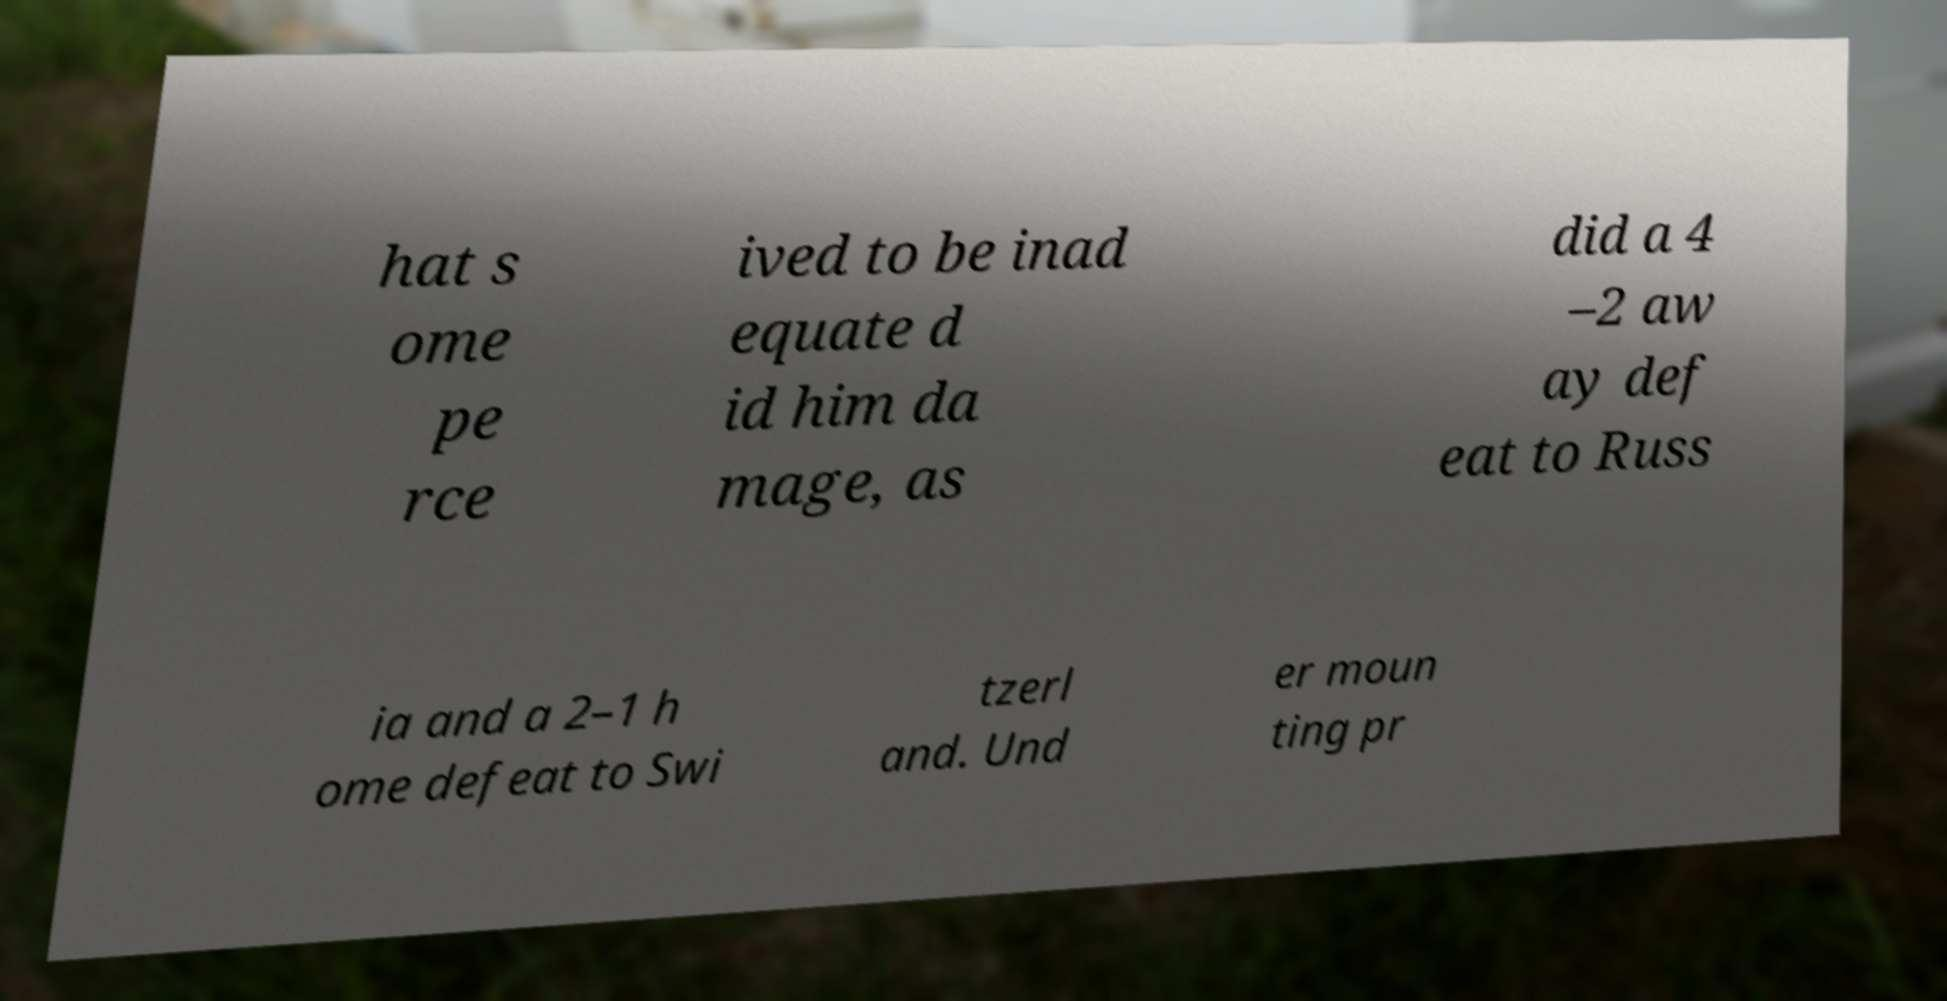For documentation purposes, I need the text within this image transcribed. Could you provide that? hat s ome pe rce ived to be inad equate d id him da mage, as did a 4 –2 aw ay def eat to Russ ia and a 2–1 h ome defeat to Swi tzerl and. Und er moun ting pr 